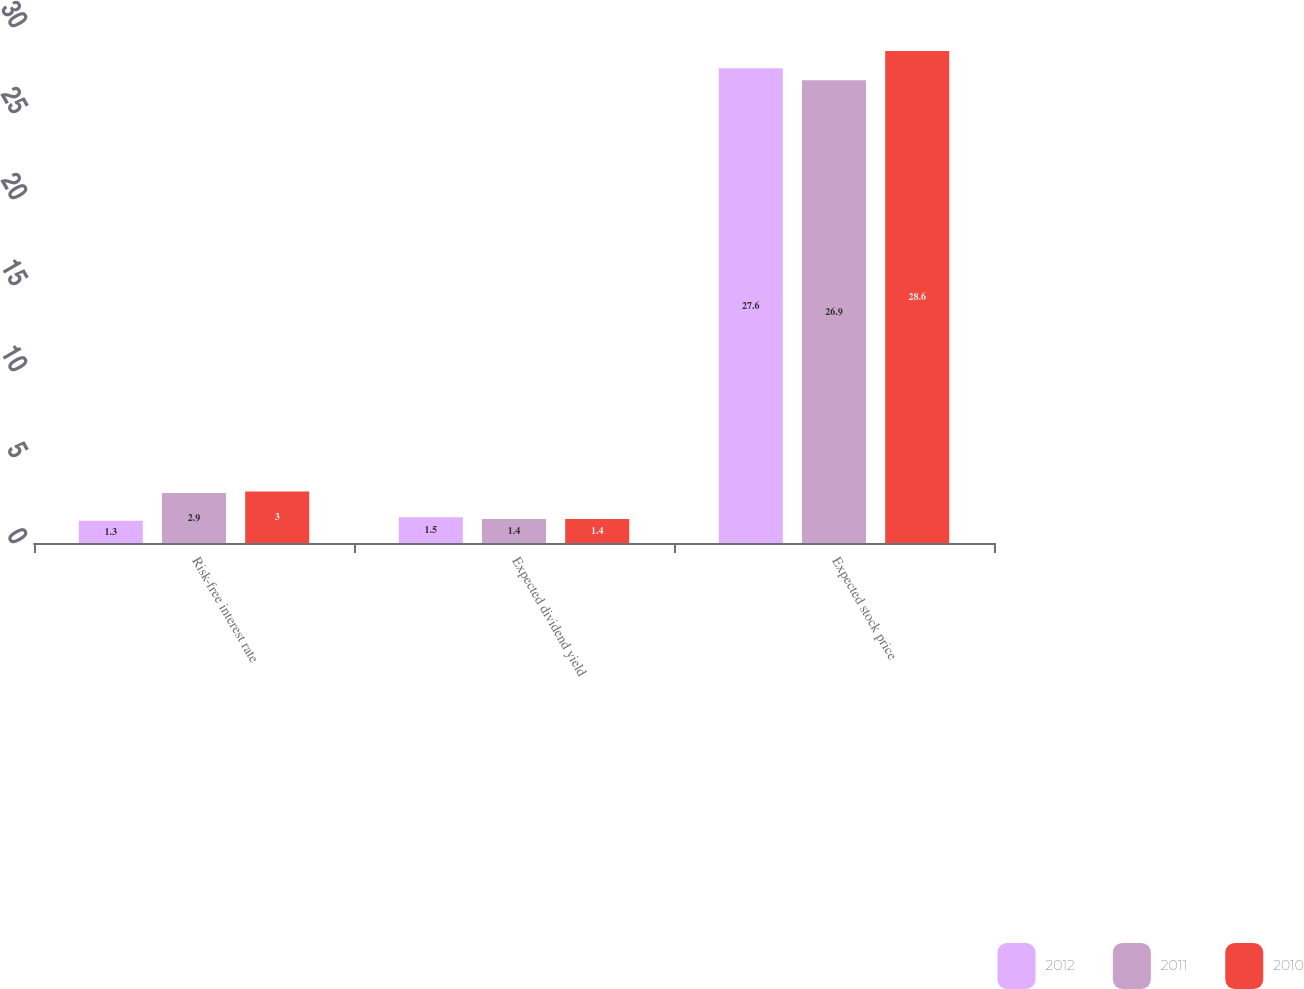<chart> <loc_0><loc_0><loc_500><loc_500><stacked_bar_chart><ecel><fcel>Risk-free interest rate<fcel>Expected dividend yield<fcel>Expected stock price<nl><fcel>2012<fcel>1.3<fcel>1.5<fcel>27.6<nl><fcel>2011<fcel>2.9<fcel>1.4<fcel>26.9<nl><fcel>2010<fcel>3<fcel>1.4<fcel>28.6<nl></chart> 